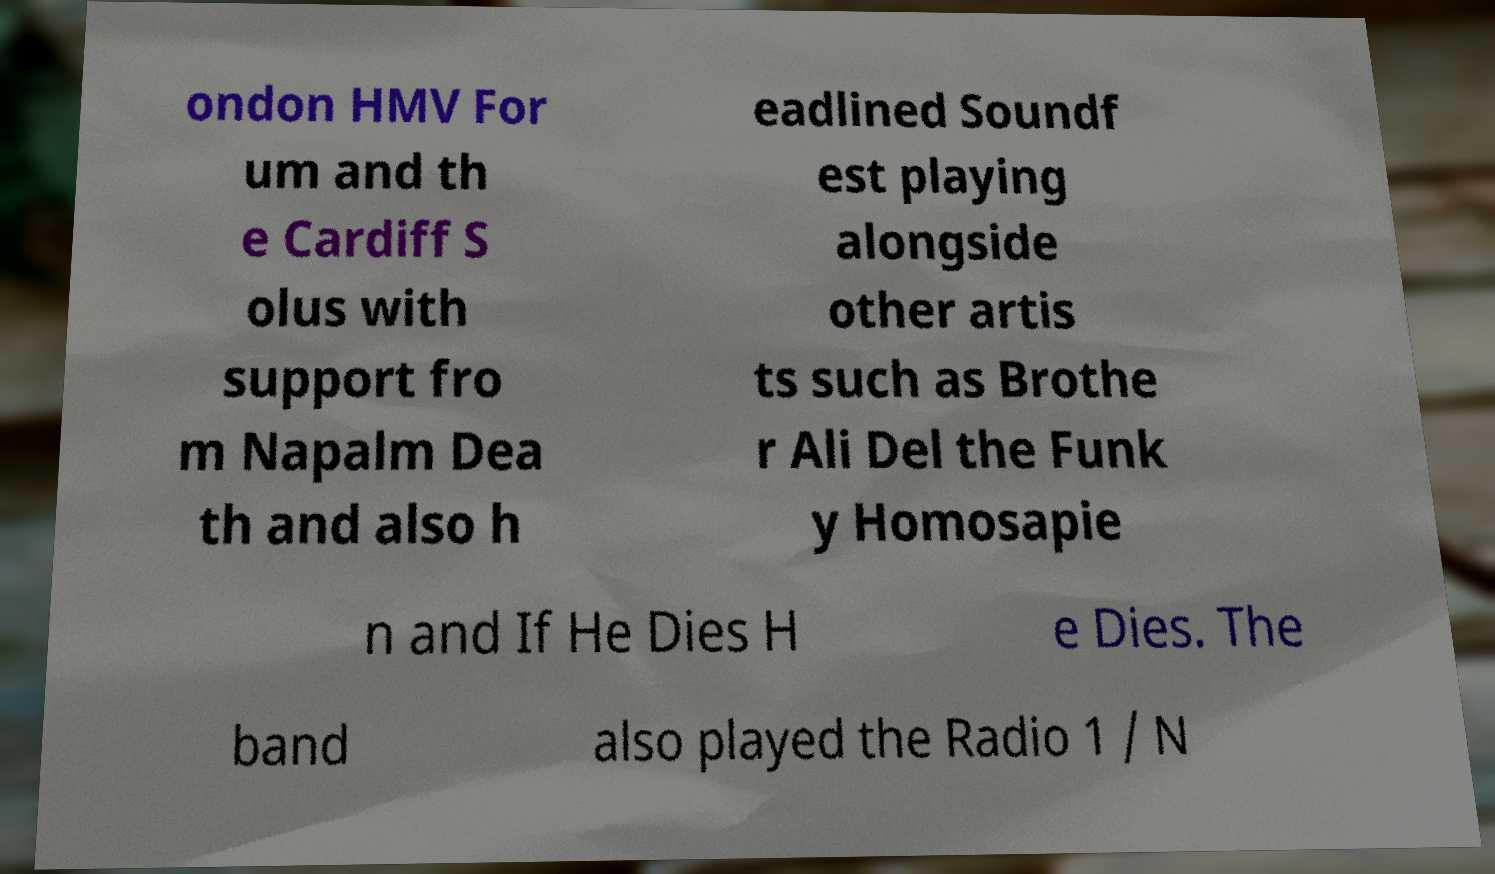Can you read and provide the text displayed in the image?This photo seems to have some interesting text. Can you extract and type it out for me? ondon HMV For um and th e Cardiff S olus with support fro m Napalm Dea th and also h eadlined Soundf est playing alongside other artis ts such as Brothe r Ali Del the Funk y Homosapie n and If He Dies H e Dies. The band also played the Radio 1 / N 